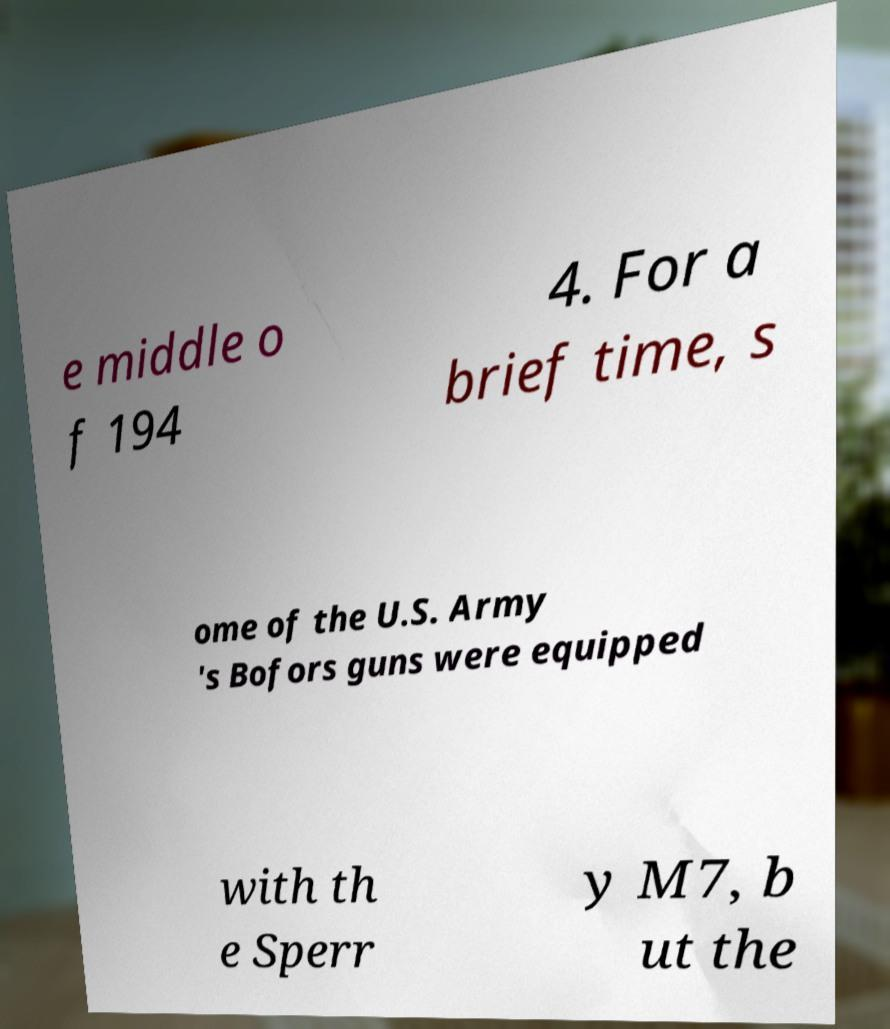There's text embedded in this image that I need extracted. Can you transcribe it verbatim? e middle o f 194 4. For a brief time, s ome of the U.S. Army 's Bofors guns were equipped with th e Sperr y M7, b ut the 